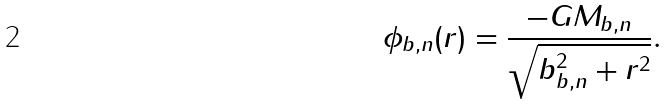Convert formula to latex. <formula><loc_0><loc_0><loc_500><loc_500>\phi _ { b , n } ( r ) = \frac { - G M _ { b , n } } { \sqrt { b _ { b , n } ^ { 2 } + r ^ { 2 } } } .</formula> 